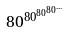Convert formula to latex. <formula><loc_0><loc_0><loc_500><loc_500>8 0 ^ { 8 0 ^ { 8 0 ^ { 8 0 ^ { \dots } } } }</formula> 